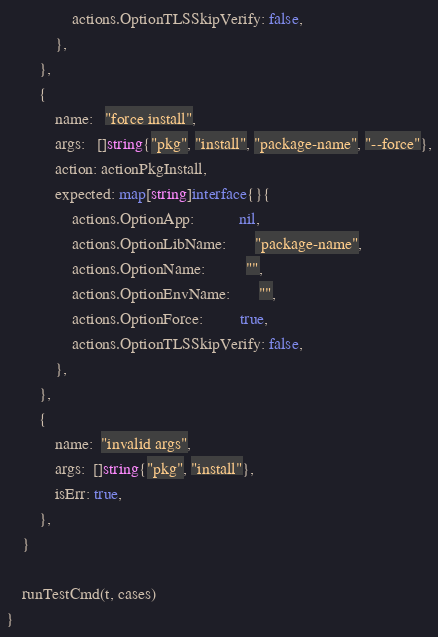Convert code to text. <code><loc_0><loc_0><loc_500><loc_500><_Go_>				actions.OptionTLSSkipVerify: false,
			},
		},
		{
			name:   "force install",
			args:   []string{"pkg", "install", "package-name", "--force"},
			action: actionPkgInstall,
			expected: map[string]interface{}{
				actions.OptionApp:           nil,
				actions.OptionLibName:       "package-name",
				actions.OptionName:          "",
				actions.OptionEnvName:       "",
				actions.OptionForce:         true,
				actions.OptionTLSSkipVerify: false,
			},
		},
		{
			name:  "invalid args",
			args:  []string{"pkg", "install"},
			isErr: true,
		},
	}

	runTestCmd(t, cases)
}
</code> 